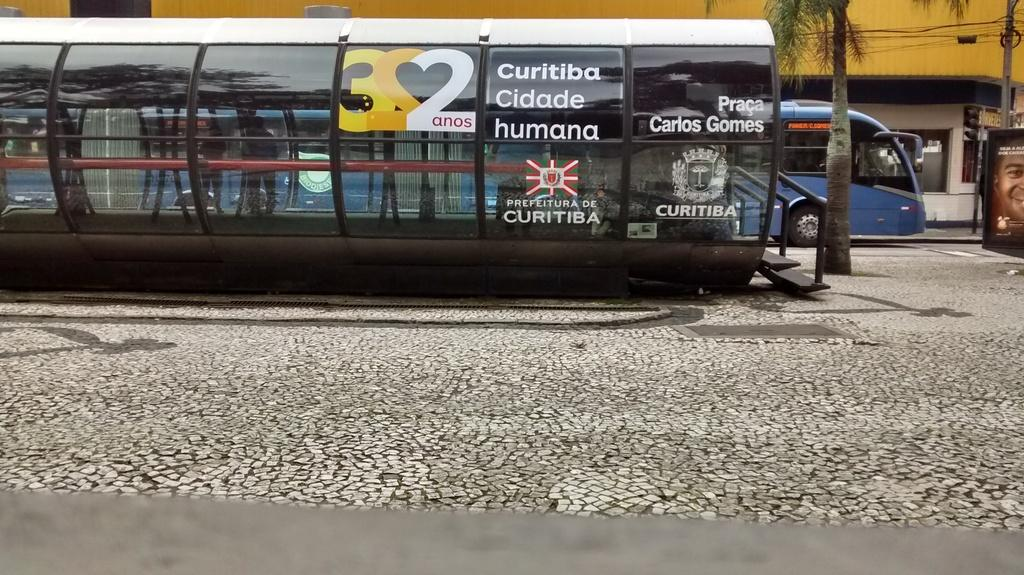<image>
Create a compact narrative representing the image presented. Curitiba Cidade Humana Bus sign that has a Bus parked in blue next to it. 